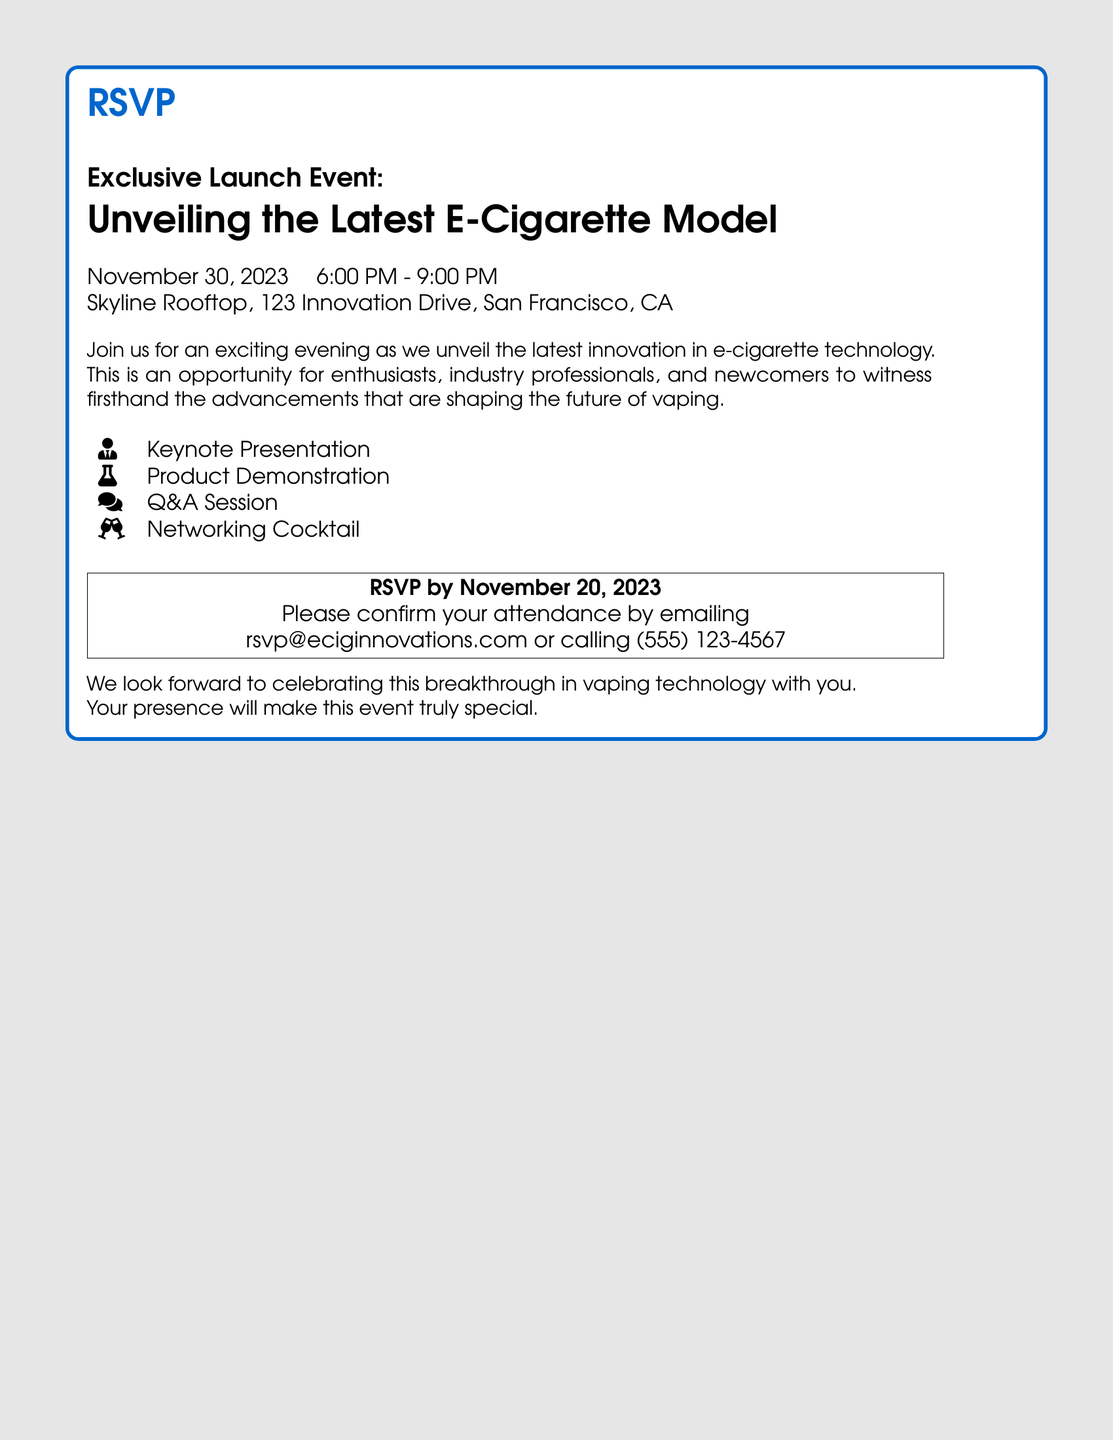What is the date of the event? The event date is explicitly mentioned in the document as November 30, 2023.
Answer: November 30, 2023 What time does the event start? The starting time of the event is listed in the document as 6:00 PM.
Answer: 6:00 PM Where is the event taking place? The document provides the location of the event: Skyline Rooftop, 123 Innovation Drive, San Francisco, CA.
Answer: Skyline Rooftop, 123 Innovation Drive, San Francisco, CA What should attendees do to RSVP? The document states that to RSVP, attendees should email or call the provided contact information.
Answer: Email rsvp@eciginnovations.com or call (555) 123-4567 When is the RSVP deadline? The document specifies that the RSVP needs to be completed by November 20, 2023.
Answer: November 20, 2023 What type of session will be held after the product demonstration? The document mentions a Q&A session following the product demonstration.
Answer: Q&A Session What is the primary focus of the event? The main purpose of the event, as stated in the document, is to unveil the latest innovation in e-cigarette technology.
Answer: Unveiling the Latest E-Cigarette Model What can attendees expect to do during the event? The document includes several activities, including a keynote presentation and networking cocktail.
Answer: Keynote Presentation, Networking Cocktail 